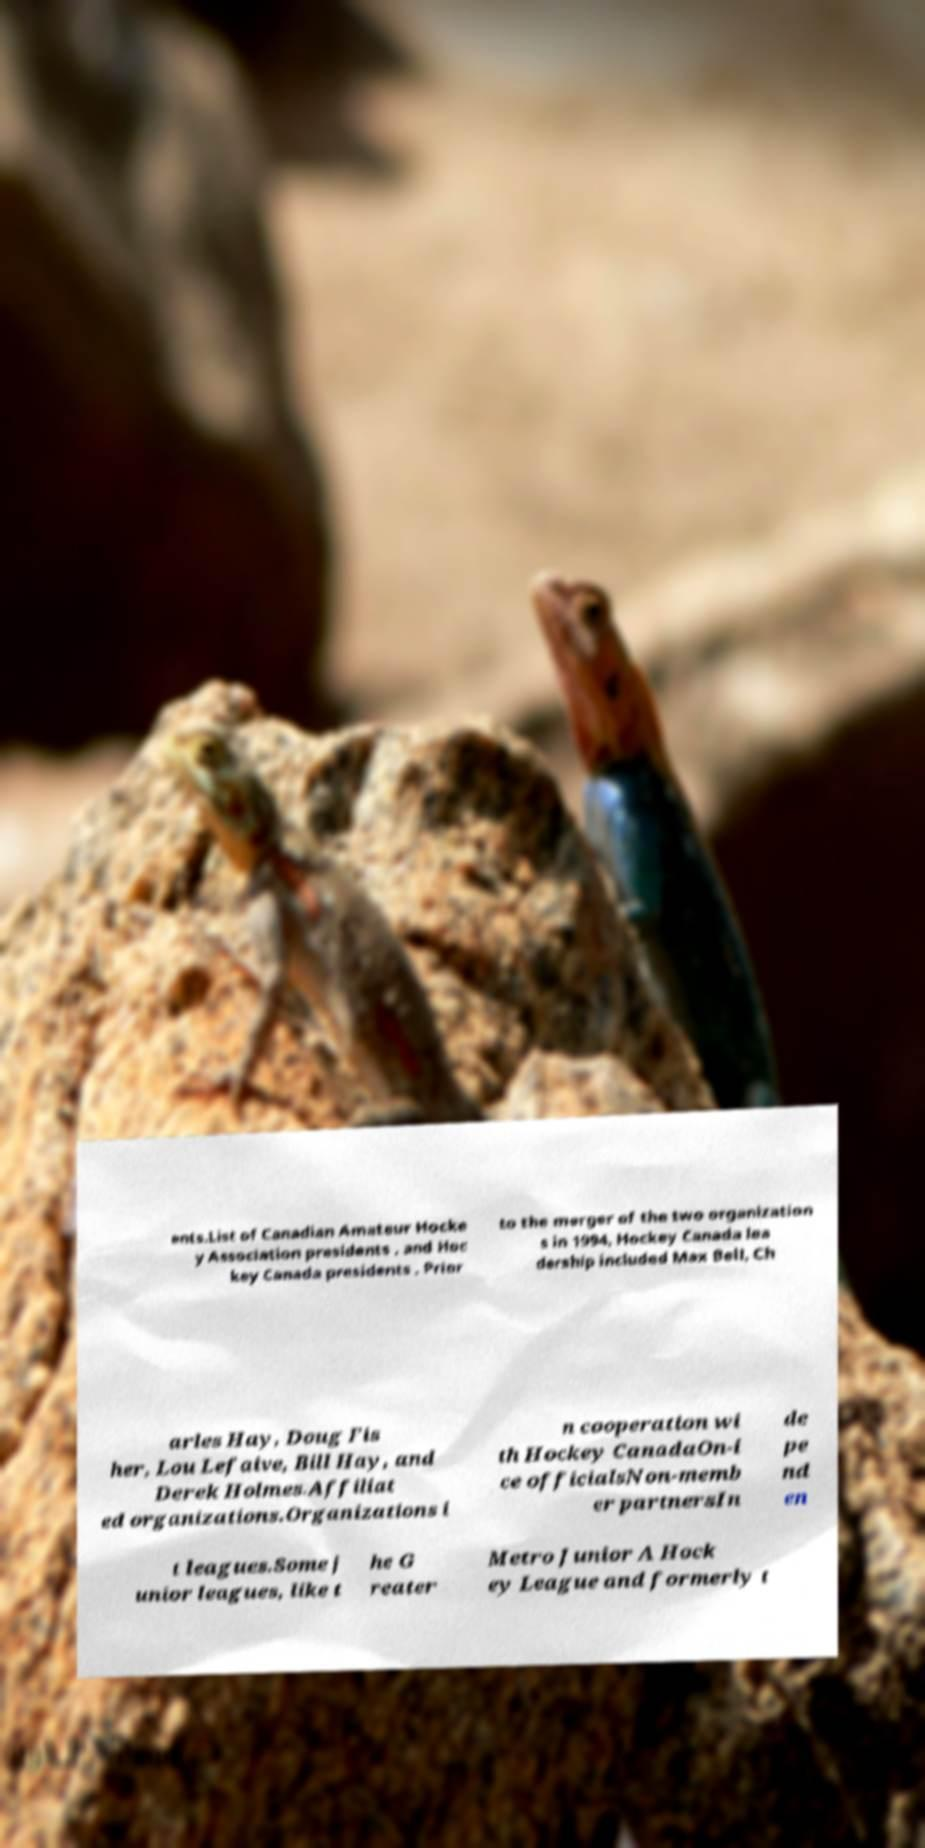For documentation purposes, I need the text within this image transcribed. Could you provide that? ents.List of Canadian Amateur Hocke y Association presidents , and Hoc key Canada presidents . Prior to the merger of the two organization s in 1994, Hockey Canada lea dership included Max Bell, Ch arles Hay, Doug Fis her, Lou Lefaive, Bill Hay, and Derek Holmes.Affiliat ed organizations.Organizations i n cooperation wi th Hockey CanadaOn-i ce officialsNon-memb er partnersIn de pe nd en t leagues.Some j unior leagues, like t he G reater Metro Junior A Hock ey League and formerly t 